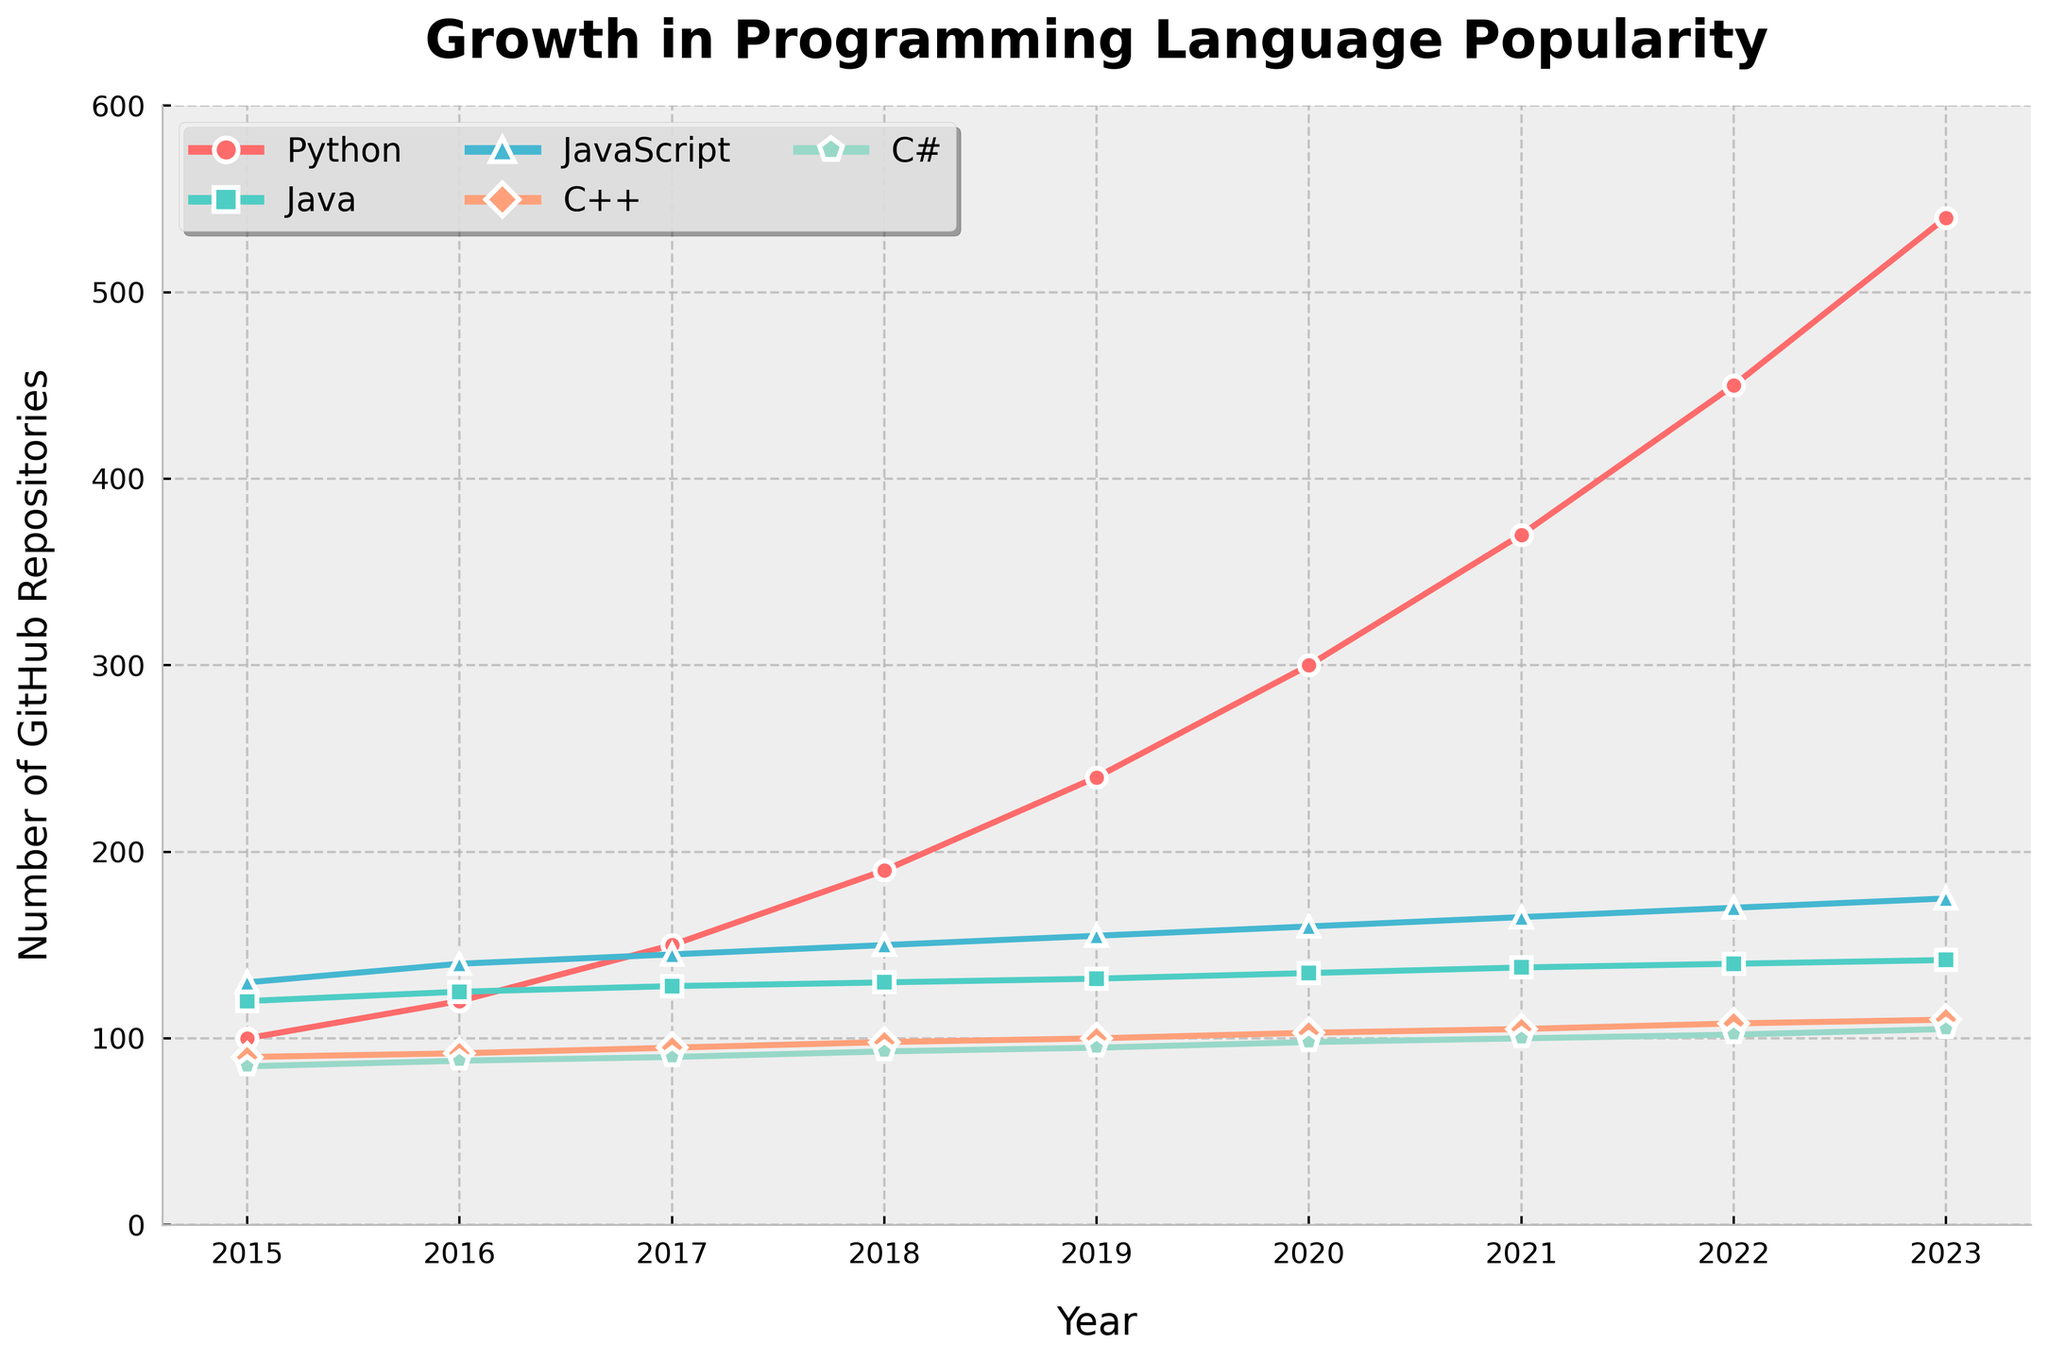Which language had the highest number of GitHub repositories in 2022? To determine this, look at the data points for the year 2022 in the chart. Python has the highest value of about 450.
Answer: Python Compare the growth of Python and C# from 2015 to 2023. Which grew more? The number of GitHub repositories for Python increased from 100 to 540 (an increase of 440), whereas for C# it increased from 85 to 105 (an increase of 20). Thus, Python grew more.
Answer: Python In what year did Python surpass 200 repositories? By inspecting the line for Python, we see that it crossed 200 repositories between 2018 and 2019. In 2019, it had 240 repositories.
Answer: 2019 What is the total increase in the number of JavaScript repositories from 2015 to 2023? In 2015, JavaScript had 130 repositories. In 2023, it had 175. So, the increase is 175 - 130 = 45.
Answer: 45 How many more GitHub repositories did C++ have compared to C# in 2020? In 2020, C++ had 103 repositories and C# had 98 repositories. The difference is 103 - 98 = 5.
Answer: 5 Which language experienced the least growth from 2015 to 2023? By comparing the differences from 2015 to 2023 for all languages (Python: 440, Java: 22, JavaScript: 45, C++: 20, C#: 20), it's clear that C++ and C# both experienced the least growth of 20.
Answer: C++ and C# Which language had the smallest number of repositories in 2015? By comparing the values for 2015, C# had the smallest number of repositories with 85.
Answer: C# In which year did JavaScript first have more repositories than Java? Looking at the data points, JavaScript first surpassed Java between 2015 and 2016 and continued having more repositories. In 2016, JavaScript had 140 repositories while Java had 125.
Answer: 2016 Between 2016 and 2023, which language had the most significant increase in the number of repositories each year, on average? Calculate the average annual growth for each language by subtracting the initial value in 2016 from the final value in 2023 and dividing by the number of years (7). Python: (540-120)/7 = 60; Java: (142-125)/7 = 2.43; JavaScript: (175-140)/7 = 5; C++: (110-92)/7 = 2.57; C#: (105-88)/7 = 2.43. Python had the most significant annual increase of 60 repositories per year.
Answer: Python 